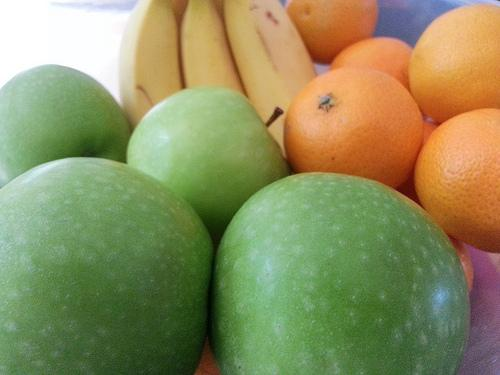In a short sentence, summarize the contents of the image. The image features different fruits, including green apples, oranges, and ripe yellow bananas. Describe the scene in the image in a concise manner. Various pieces of fruit, including apples, oranges, and bananas, are arranged on a surface. In a short sentence, state the types of fruits and their general arrangement in the image. The image shows a bunch of bananas, green apples with light spots, and oranges piled together. Briefly describe the variety of fruits and their condition in the image. There are green apples with light spots, ripe yellow bananas, and oranges piled together in the picture. Summarize the key features and elements of the image. The image consists of green apples with white spots, a pile of oranges, and a group of ripe yellow bananas on a surface. Identify the primary fruits seen in the image and state their colors. Green apples, yellow bananas, and oranges are the main fruits visible in the image. Provide a concise description of the fruits and their arrangement in the image. The image showcases green apples with white spots, a group of ripe yellow bananas, and a pile of oranges. Give a brief account of the colors and characteristics of the fruits in the picture. The image displays green apples with white spots, yellow bananas, and oranges, all arranged on a surface. Provide a brief description of the primary fruit in the picture. There are several green apples with white spots, lying close to a bunch of yellow bananas. Mention the fruits displayed in the image and their most noticeable traits. Green apples with white spots, ripe yellow bananas, and a pile of oranges can be seen in the image. 